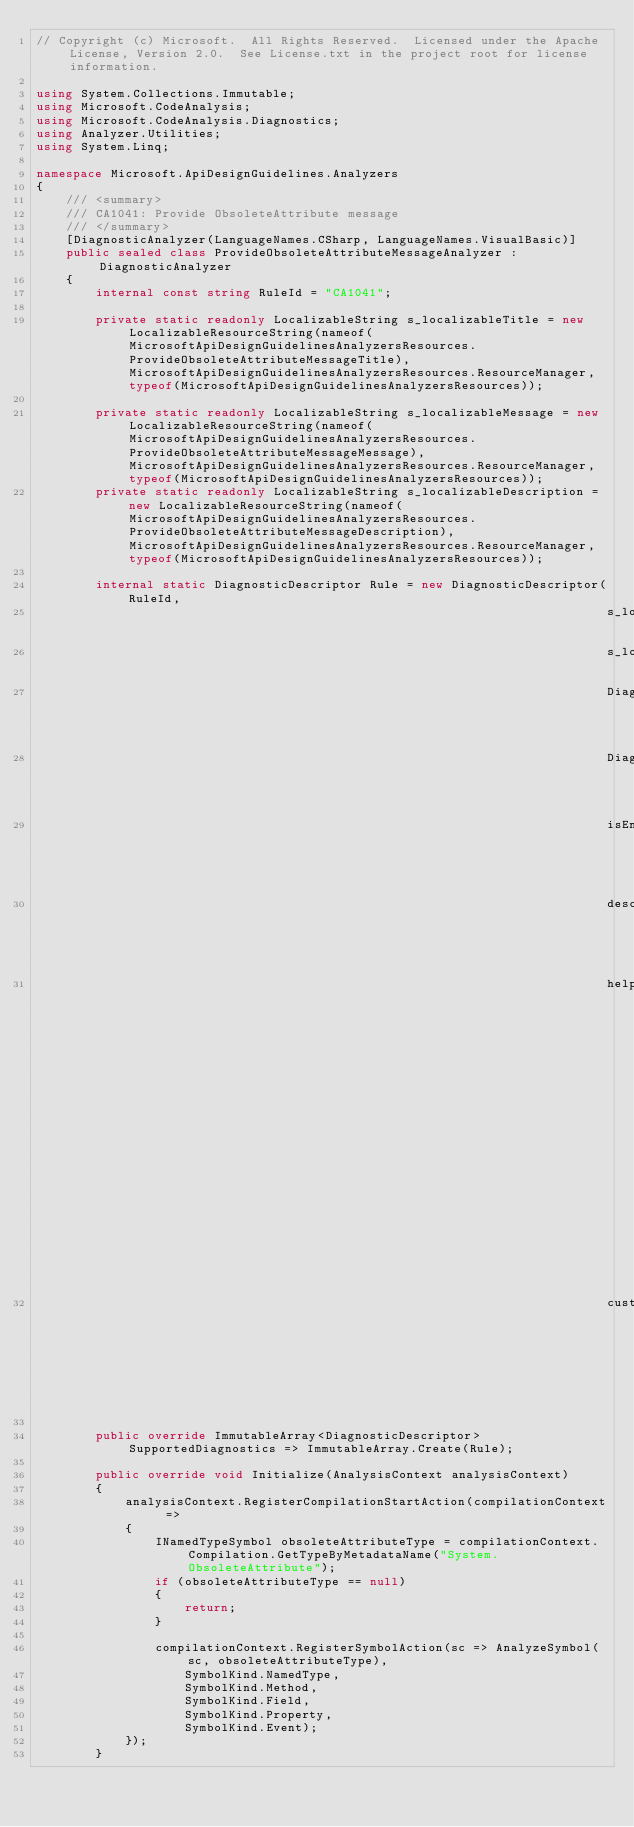Convert code to text. <code><loc_0><loc_0><loc_500><loc_500><_C#_>// Copyright (c) Microsoft.  All Rights Reserved.  Licensed under the Apache License, Version 2.0.  See License.txt in the project root for license information.

using System.Collections.Immutable;
using Microsoft.CodeAnalysis;
using Microsoft.CodeAnalysis.Diagnostics;
using Analyzer.Utilities;
using System.Linq;

namespace Microsoft.ApiDesignGuidelines.Analyzers
{
    /// <summary>
    /// CA1041: Provide ObsoleteAttribute message
    /// </summary>
    [DiagnosticAnalyzer(LanguageNames.CSharp, LanguageNames.VisualBasic)]
    public sealed class ProvideObsoleteAttributeMessageAnalyzer : DiagnosticAnalyzer
    {
        internal const string RuleId = "CA1041";

        private static readonly LocalizableString s_localizableTitle = new LocalizableResourceString(nameof(MicrosoftApiDesignGuidelinesAnalyzersResources.ProvideObsoleteAttributeMessageTitle), MicrosoftApiDesignGuidelinesAnalyzersResources.ResourceManager, typeof(MicrosoftApiDesignGuidelinesAnalyzersResources));

        private static readonly LocalizableString s_localizableMessage = new LocalizableResourceString(nameof(MicrosoftApiDesignGuidelinesAnalyzersResources.ProvideObsoleteAttributeMessageMessage), MicrosoftApiDesignGuidelinesAnalyzersResources.ResourceManager, typeof(MicrosoftApiDesignGuidelinesAnalyzersResources));
        private static readonly LocalizableString s_localizableDescription = new LocalizableResourceString(nameof(MicrosoftApiDesignGuidelinesAnalyzersResources.ProvideObsoleteAttributeMessageDescription), MicrosoftApiDesignGuidelinesAnalyzersResources.ResourceManager, typeof(MicrosoftApiDesignGuidelinesAnalyzersResources));

        internal static DiagnosticDescriptor Rule = new DiagnosticDescriptor(RuleId,
                                                                             s_localizableTitle,
                                                                             s_localizableMessage,
                                                                             DiagnosticCategory.Design,
                                                                             DiagnosticSeverity.Warning,
                                                                             isEnabledByDefault: true,
                                                                             description: s_localizableDescription,
                                                                             helpLinkUri: "https://msdn.microsoft.com/en-us/library/ms182166.aspx",
                                                                             customTags: WellKnownDiagnosticTags.Telemetry);

        public override ImmutableArray<DiagnosticDescriptor> SupportedDiagnostics => ImmutableArray.Create(Rule);

        public override void Initialize(AnalysisContext analysisContext)
        {
            analysisContext.RegisterCompilationStartAction(compilationContext =>
            {
                INamedTypeSymbol obsoleteAttributeType = compilationContext.Compilation.GetTypeByMetadataName("System.ObsoleteAttribute");
                if (obsoleteAttributeType == null)
                {
                    return;
                }

                compilationContext.RegisterSymbolAction(sc => AnalyzeSymbol(sc, obsoleteAttributeType),
                    SymbolKind.NamedType,
                    SymbolKind.Method,
                    SymbolKind.Field,
                    SymbolKind.Property,
                    SymbolKind.Event);
            });
        }
</code> 